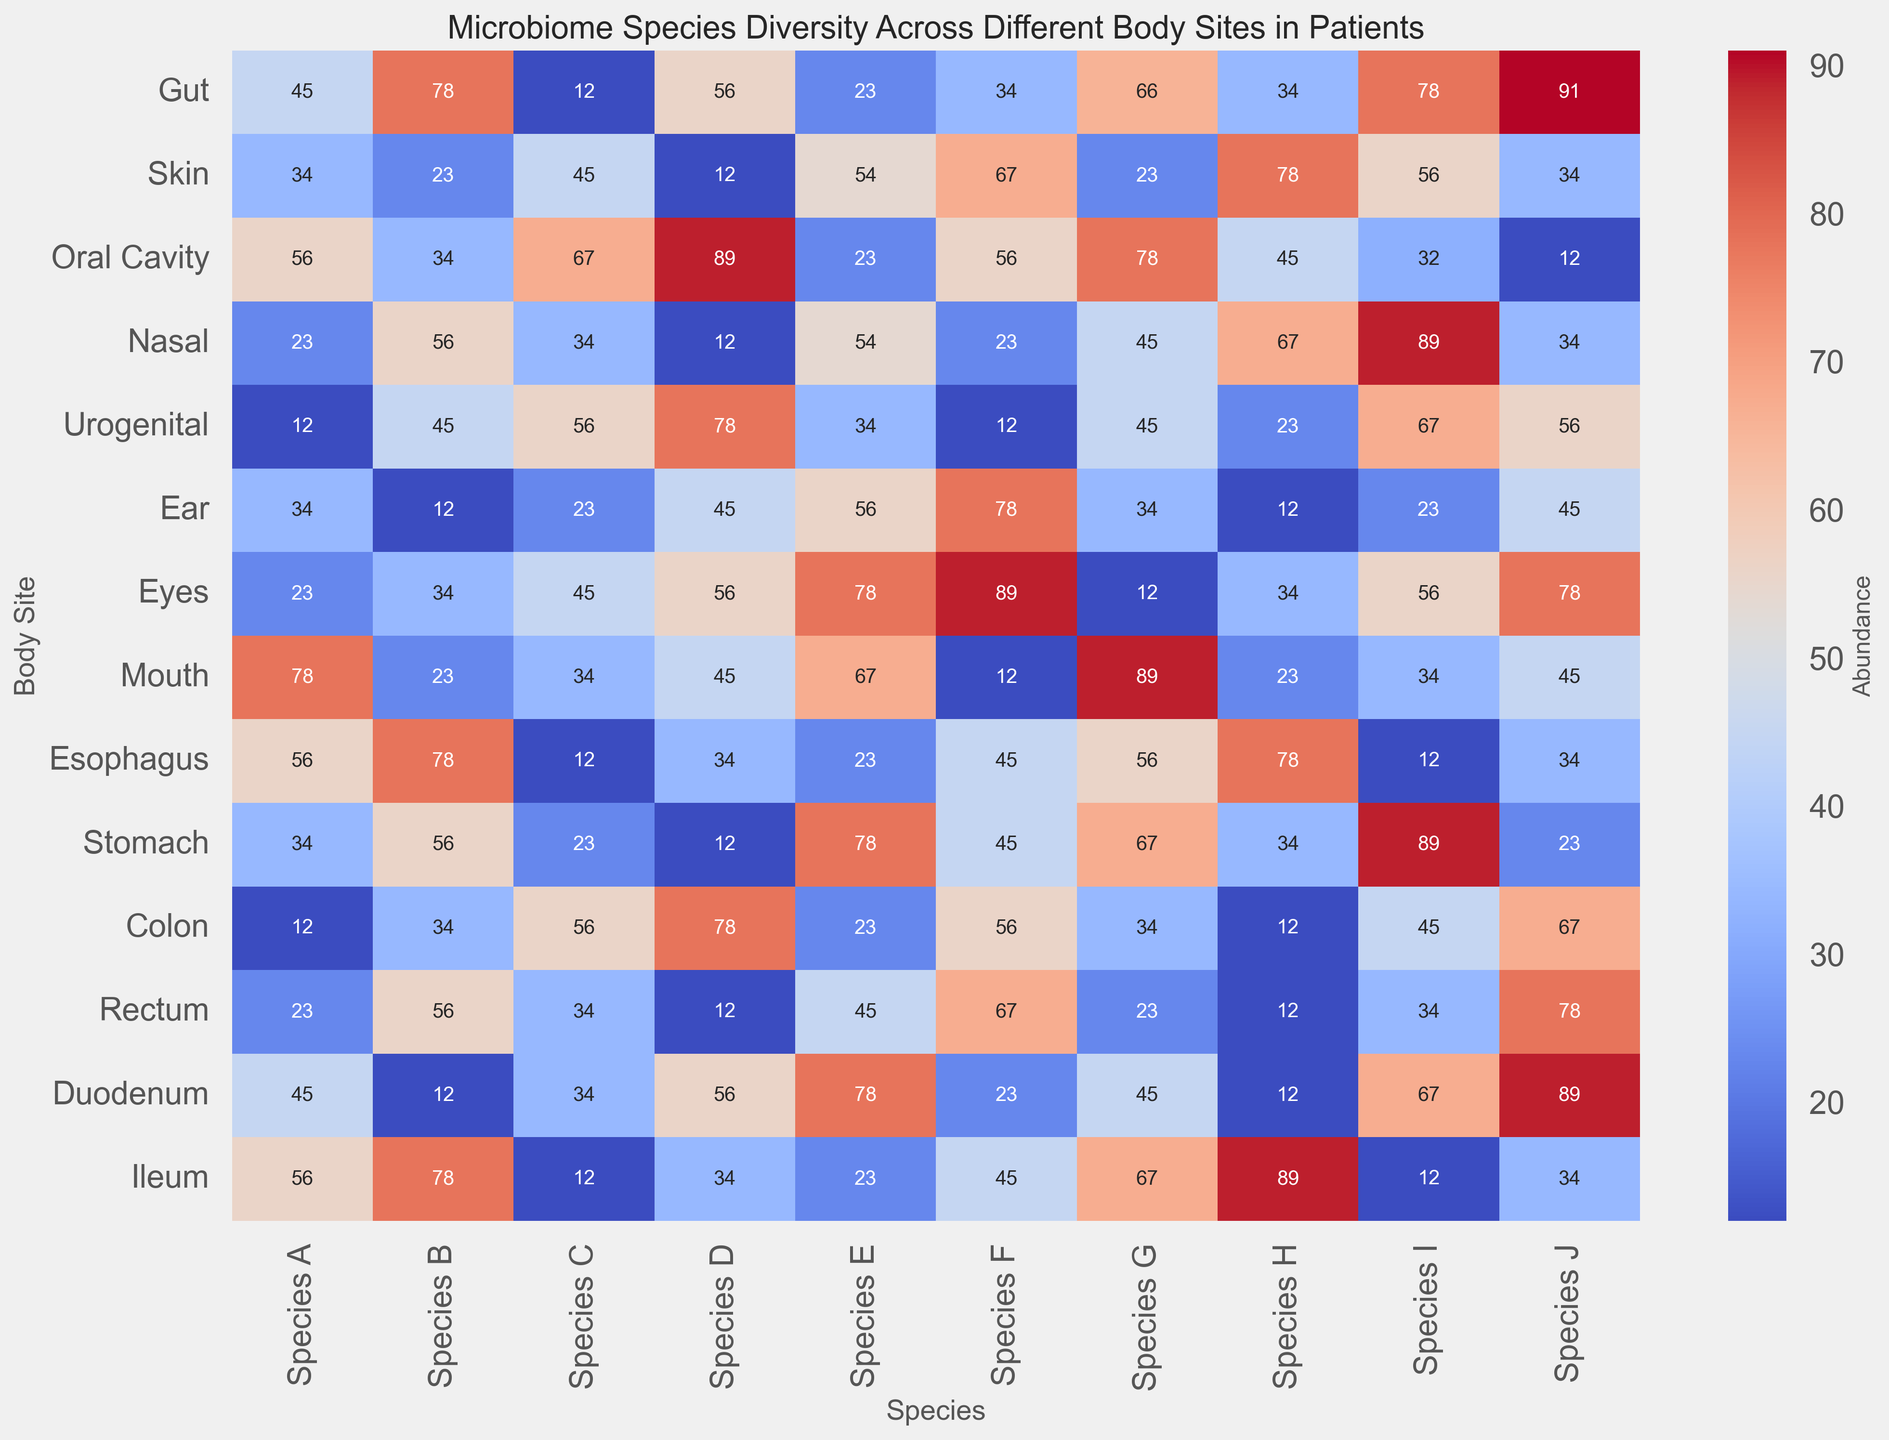Which body site has the highest abundance of Species A? Look for the highest value in the column for Species A. By comparing values, the highest is 78 in the "Ileum".
Answer: Ileum What is the total abundance of Species B in Gut and Skin? Add the abundance values for Species B in the Gut (78) and Skin (23). 78 + 23 = 101.
Answer: 101 Which species has the lowest abundance in the Oral Cavity? Check the column for Oral Cavity and find the minimum value, which is 12 for Species J.
Answer: Species J Compare the abundance of Species F in the Stomach and Colon. Which one is higher? The abundance of Species F in the Stomach is 45, and in the Colon, it is 56. Since 56 is greater than 45, Colon has a higher abundance.
Answer: Colon Are there any body sites where the abundance of Species E is equal? If so, which ones? Look for duplicate values in the Species E column. Both the Skin and Nasal have 54 as the abundance of Species E.
Answer: Skin and Nasal What is the average abundance of Species D across all body sites? Sum the values of Species D across all body sites and divide by the number of sites (14). The sum is 56+12+89+12+78+45+56+45+34+12+78+12+56+34 = 599. The average is 599/14 = 42.79.
Answer: 42.79 Which body site has the most variable distribution of species abundances? Visually assess the color variation (largest range of colors from cool to warm) across all species for each body site. The Oral Cavity shows the largest range (from very light to very dark colors).
Answer: Oral Cavity Which species shows the highest consistency in abundance across all body sites? Look for the species column with the least variation in color. Species F shows consistent and moderate levels (mostly middle shades), indicating less variability.
Answer: Species F What are the most and least abundant species in the Duodenum? Check the abundance values for Species in the Duodenum row. The most abundant is Species J with 89, while the least abundant is Species B with 12.
Answer: Most: Species J, Least: Species B 